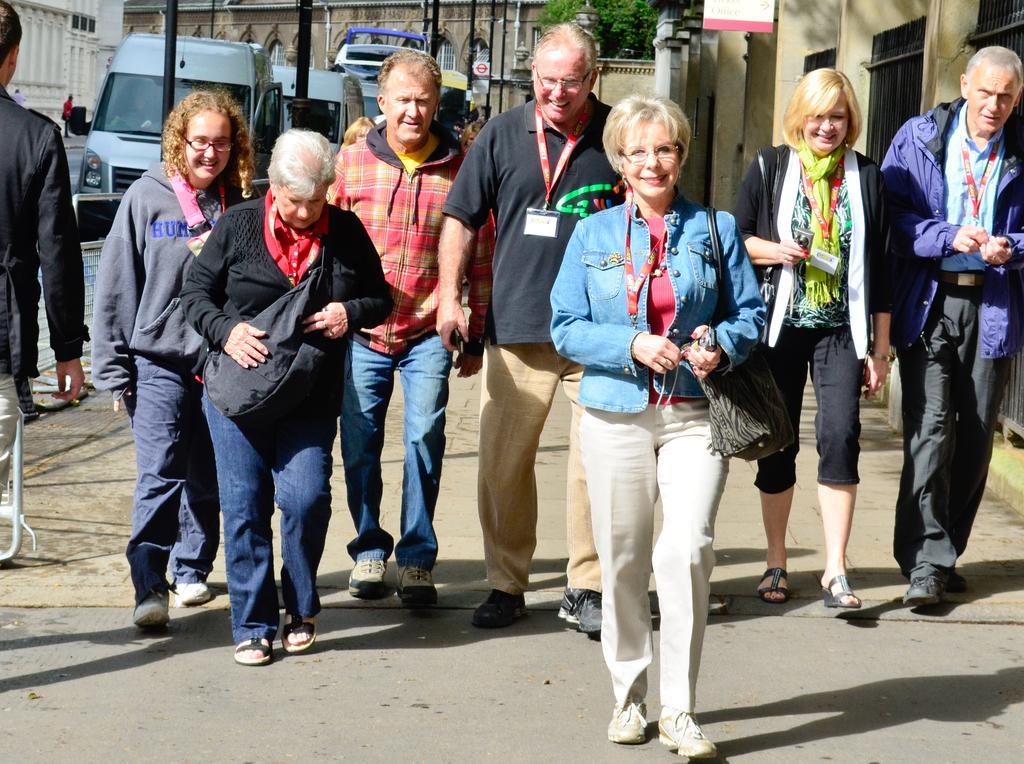In one or two sentences, can you explain what this image depicts? In the foreground of the picture there are people walking on the footpath. In the middle of the picture there are buildings, poles, vehicles, road and various objects. In the background there are buildings, trees and people. 